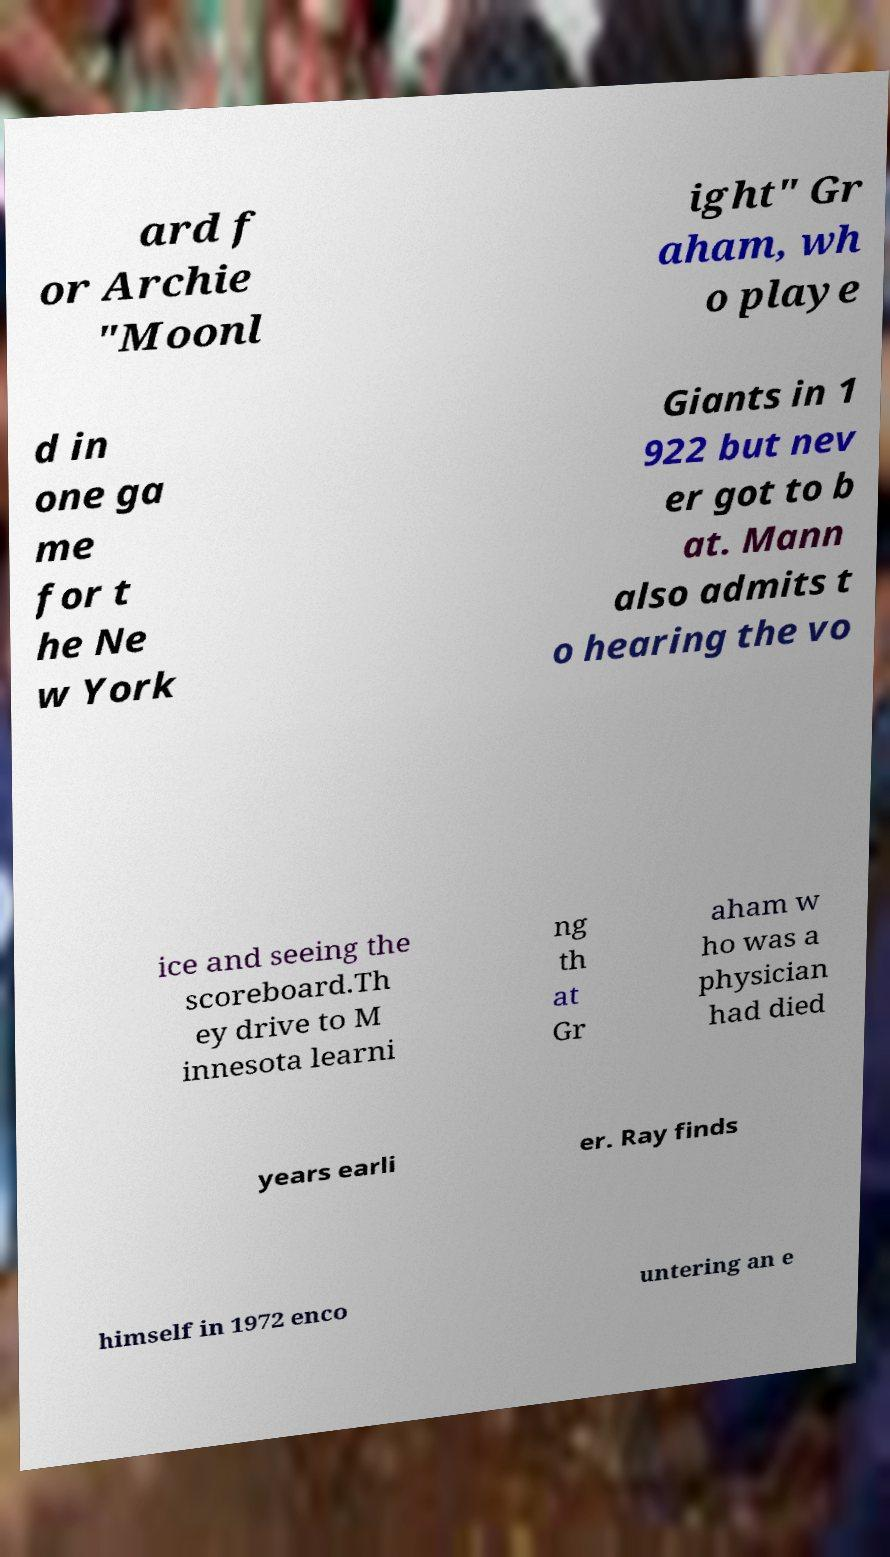There's text embedded in this image that I need extracted. Can you transcribe it verbatim? ard f or Archie "Moonl ight" Gr aham, wh o playe d in one ga me for t he Ne w York Giants in 1 922 but nev er got to b at. Mann also admits t o hearing the vo ice and seeing the scoreboard.Th ey drive to M innesota learni ng th at Gr aham w ho was a physician had died years earli er. Ray finds himself in 1972 enco untering an e 